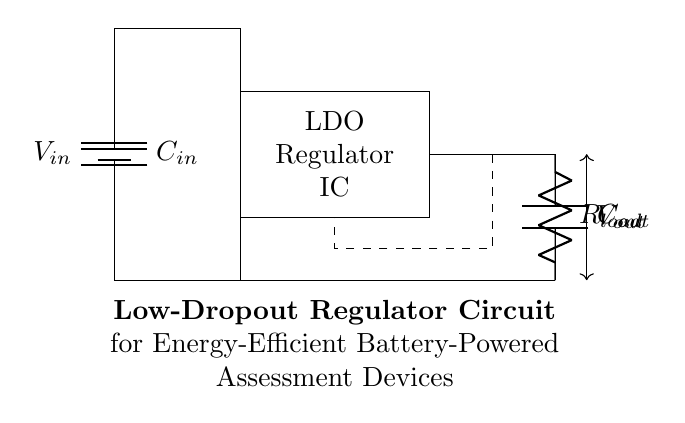What is the input voltage of the circuit? The input voltage is labeled as V in at the top of the battery symbol.
Answer: V in What is the output voltage location? The output voltage is indicated between output capacitor and load resistor at the bottom of the circuit.
Answer: V out How many capacitors are in the circuit? There are two capacitors indicated: an input capacitor and an output capacitor.
Answer: 2 What is the function of the LDO in the circuit? The LDO regulator is responsible for converting the input voltage to a lower output voltage while maintaining a constant output.
Answer: Voltage regulation What would happen to the output voltage if the input voltage drops below a certain level? If the input voltage drops below a certain level, the LDO may not maintain a constant output voltage, potentially leading to output voltage dropout.
Answer: Output voltage dropout What is the effect of the feedback line in the circuit? The feedback line helps maintain the output voltage at the desired level by feeding back a portion of the output to the regulator.
Answer: Stabilizes output voltage 